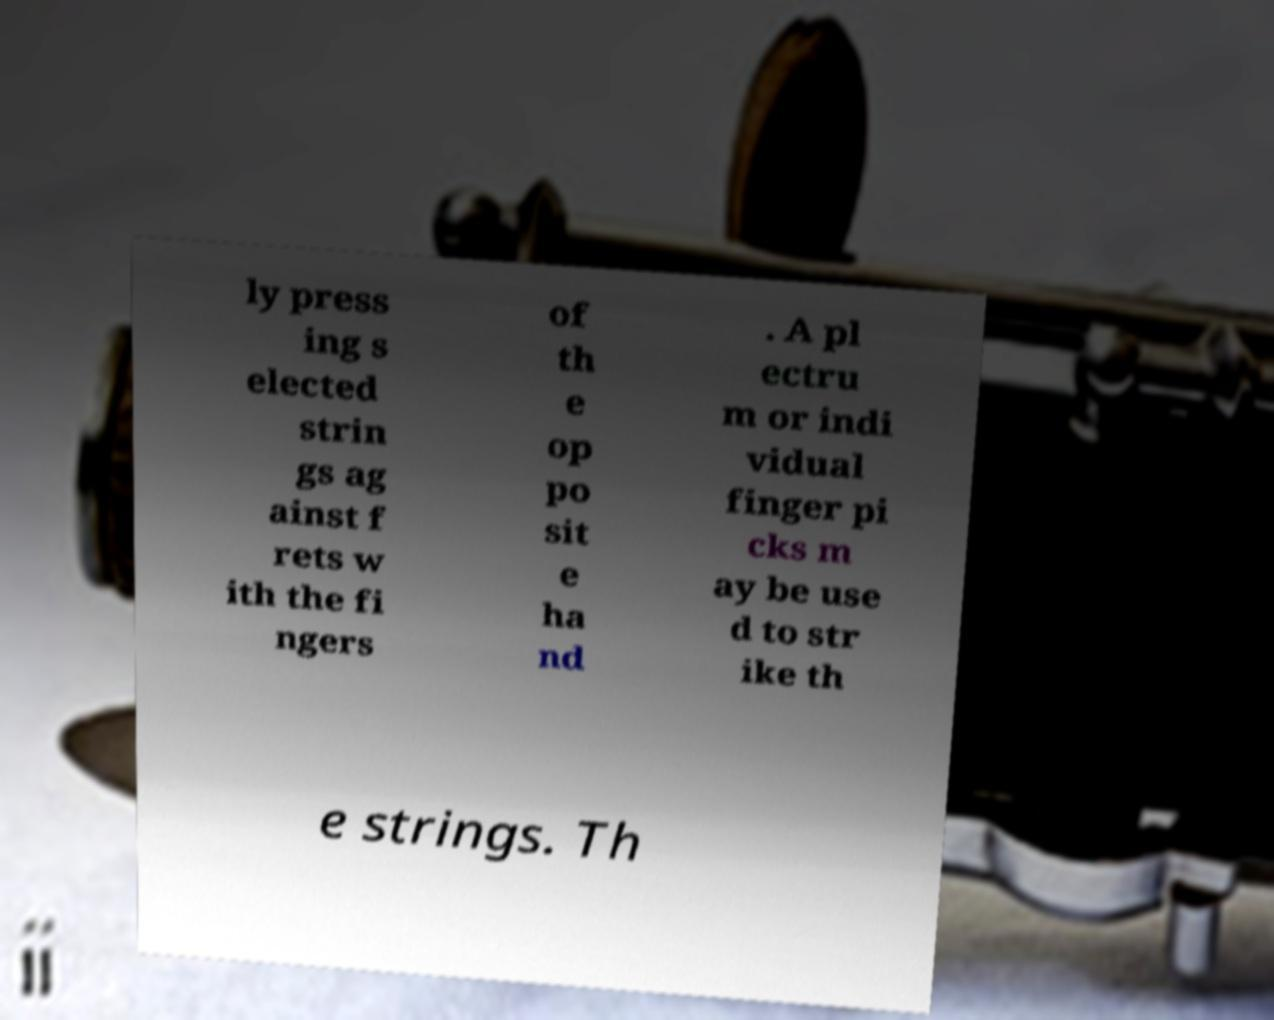Could you assist in decoding the text presented in this image and type it out clearly? ly press ing s elected strin gs ag ainst f rets w ith the fi ngers of th e op po sit e ha nd . A pl ectru m or indi vidual finger pi cks m ay be use d to str ike th e strings. Th 